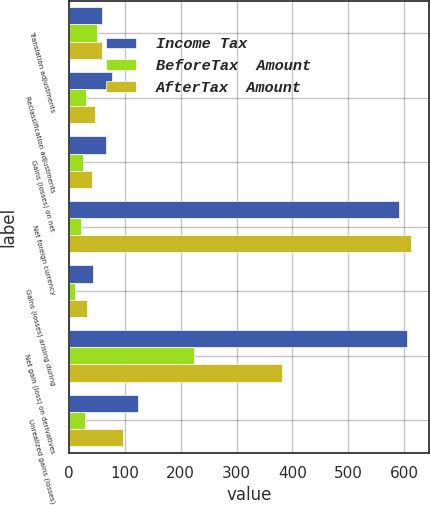Convert chart to OTSL. <chart><loc_0><loc_0><loc_500><loc_500><stacked_bar_chart><ecel><fcel>Translation adjustments<fcel>Reclassification adjustments<fcel>Gains (losses) on net<fcel>Net foreign currency<fcel>Gains (losses) arising during<fcel>Net gain (loss) on derivatives<fcel>Unrealized gains (losses)<nl><fcel>Income Tax<fcel>59<fcel>77<fcel>67<fcel>591<fcel>43<fcel>606<fcel>124<nl><fcel>BeforeTax  Amount<fcel>51<fcel>30<fcel>25<fcel>22<fcel>11<fcel>224<fcel>28<nl><fcel>AfterTax  Amount<fcel>59<fcel>47<fcel>42<fcel>613<fcel>32<fcel>382<fcel>96<nl></chart> 